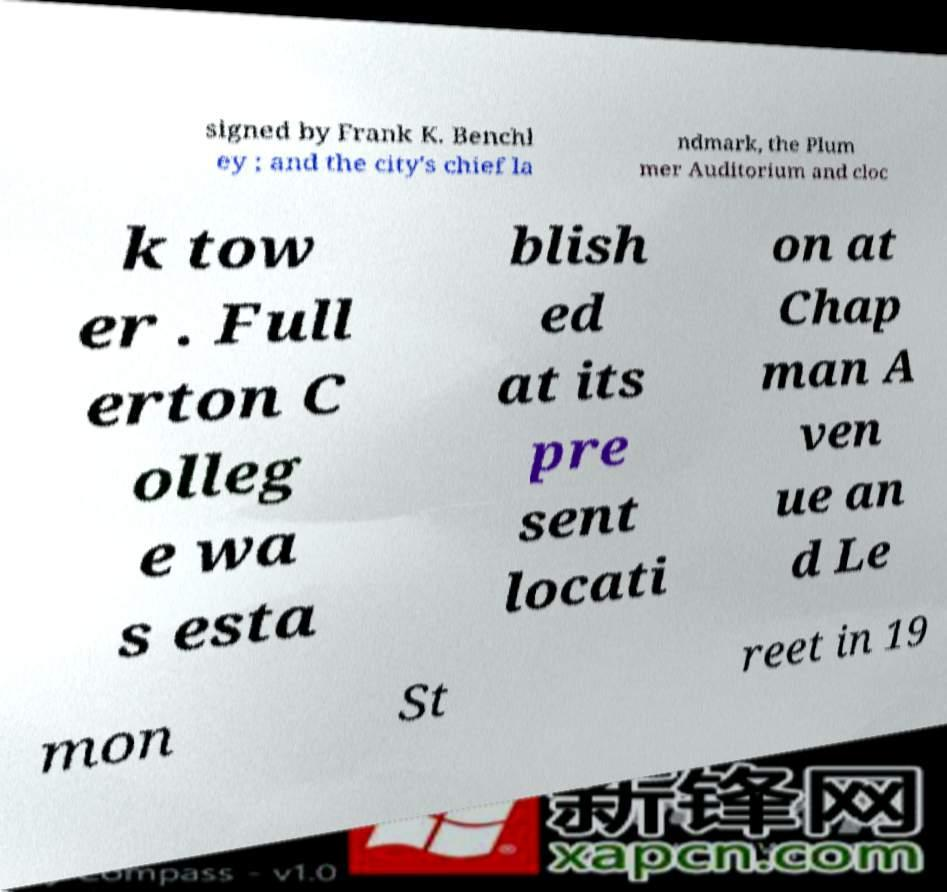Please read and relay the text visible in this image. What does it say? signed by Frank K. Benchl ey ; and the city's chief la ndmark, the Plum mer Auditorium and cloc k tow er . Full erton C olleg e wa s esta blish ed at its pre sent locati on at Chap man A ven ue an d Le mon St reet in 19 